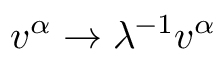Convert formula to latex. <formula><loc_0><loc_0><loc_500><loc_500>v ^ { \alpha } \rightarrow \lambda ^ { - 1 } v ^ { \alpha }</formula> 